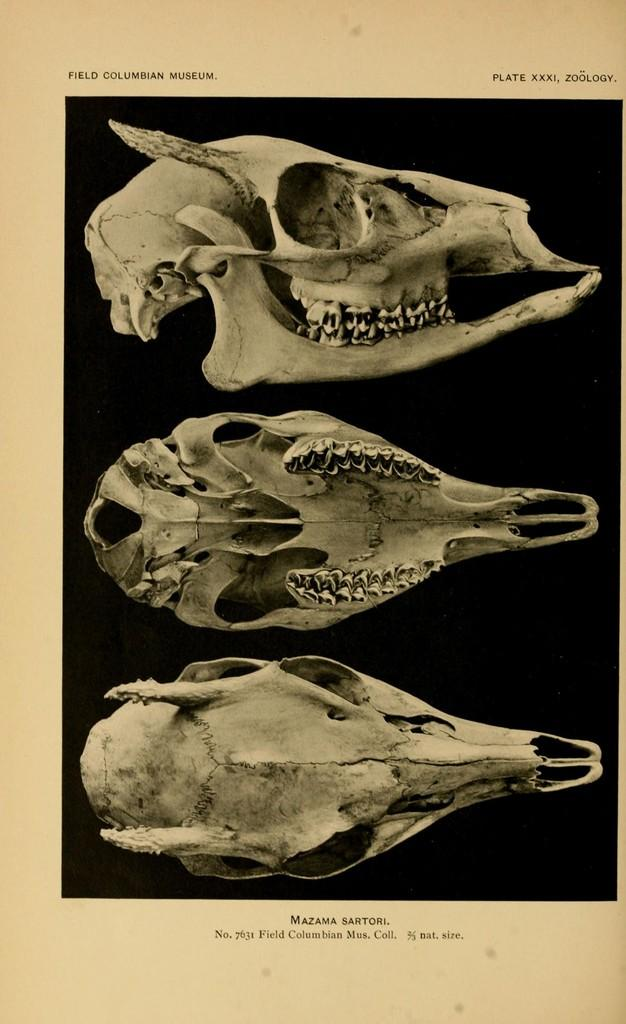What is depicted on the page in the image? There is a page in a book in the image, and it features three skulls. What else can be seen on the page? There is text on the page. How many legs are visible on the vase in the image? There is no vase present in the image, so it is not possible to determine how many legs might be visible. 